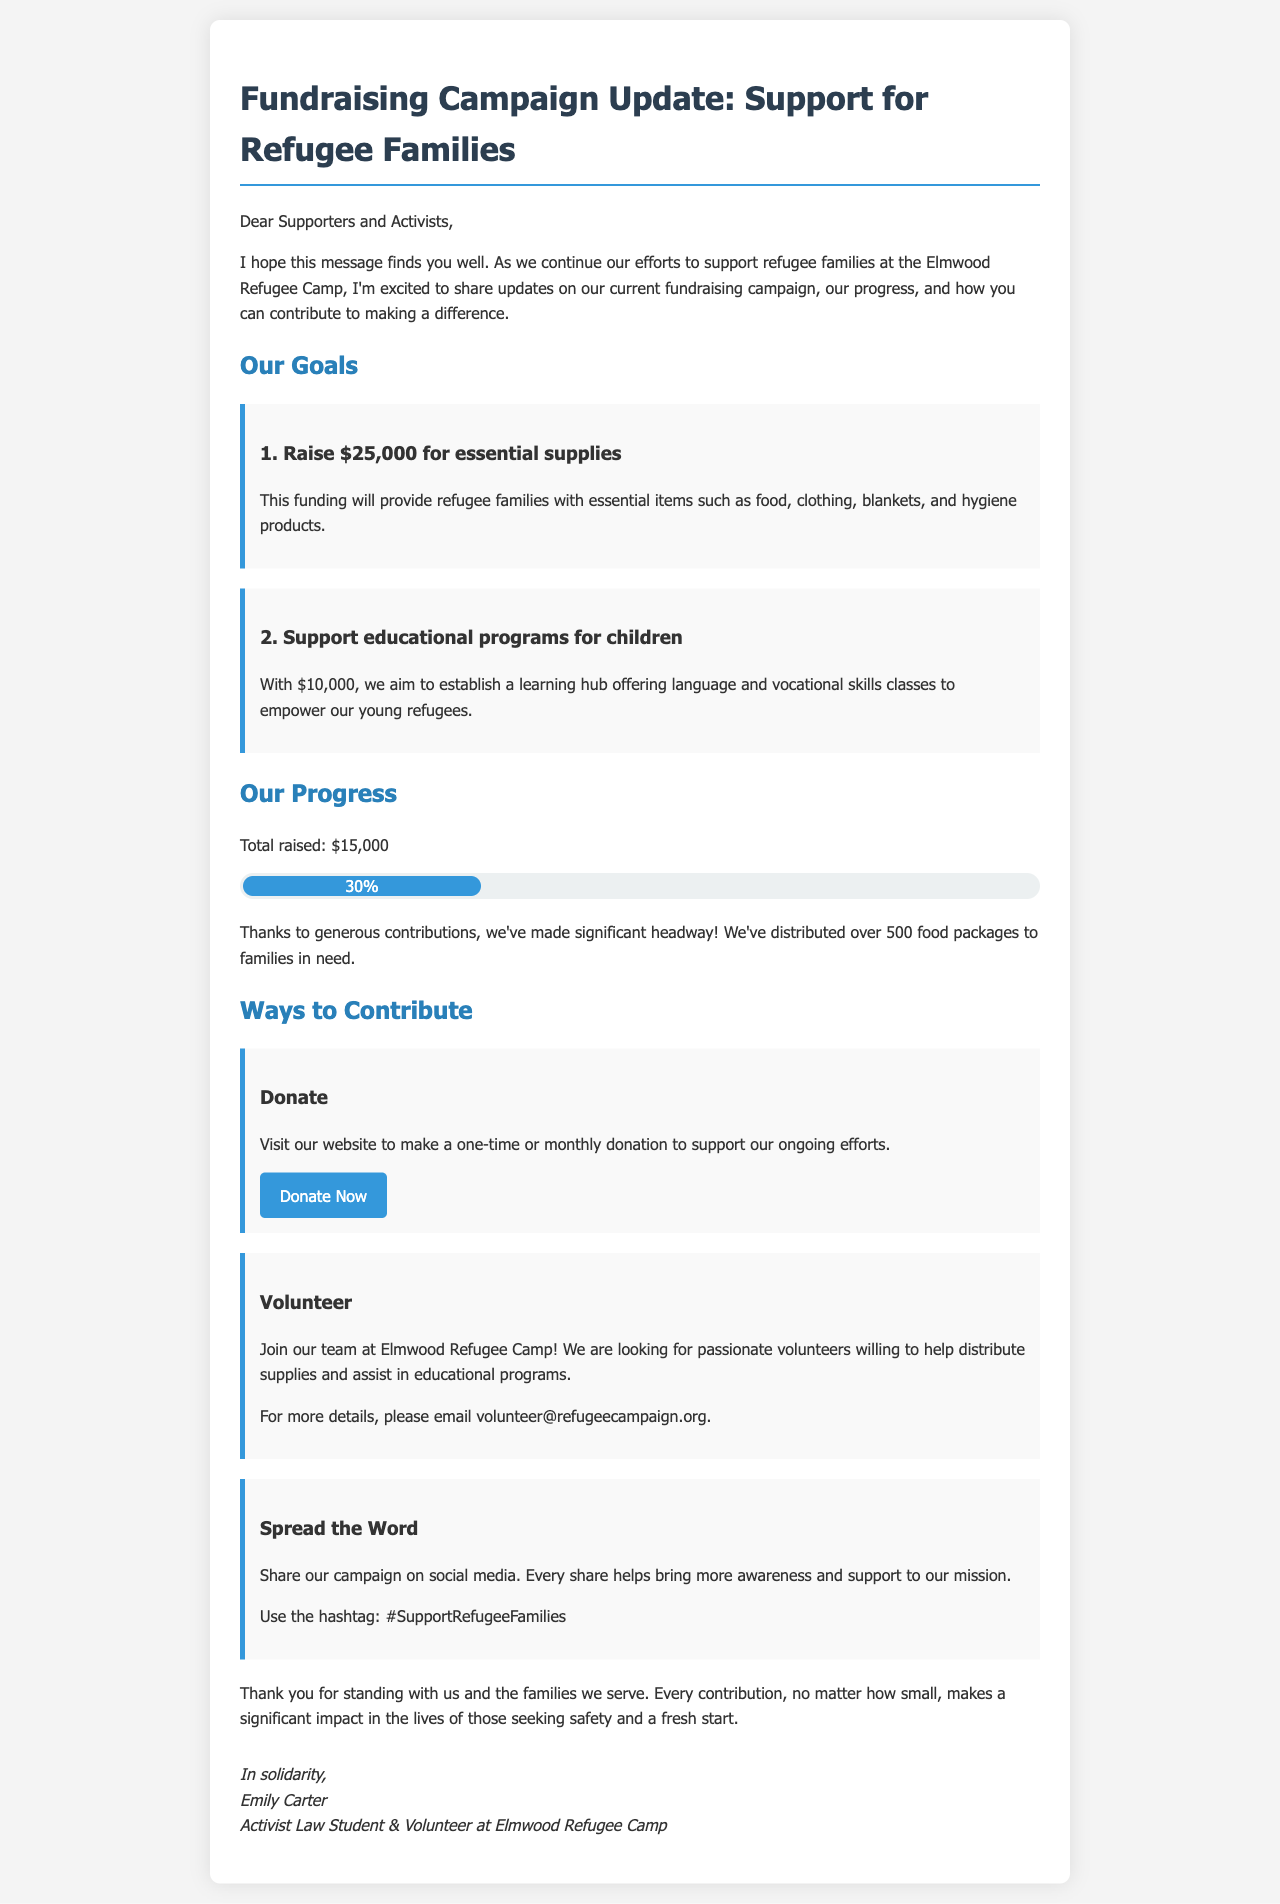What is the main fundraising goal? The main fundraising goal is to raise $25,000 for essential supplies for refugee families.
Answer: $25,000 How much has been raised so far? The document states that a total of $15,000 has been raised to date.
Answer: $15,000 What is one of the key items provided to families in need? The document mentions food as one of the essential items provided to families.
Answer: food How many food packages have been distributed? The document mentions that over 500 food packages have been distributed to families.
Answer: 500 What percentage of the goal has been achieved? The document indicates that 30% of the total fundraising goal has been achieved.
Answer: 30% Who can be contacted for volunteering opportunities? The document provides an email address for volunteering inquiries.
Answer: volunteer@refugeecampaign.org What is a way to spread awareness about the campaign? The document suggests sharing the campaign on social media as a way to spread awareness.
Answer: share on social media What is the purpose of the educational programs mentioned? The educational programs aim to empower young refugees with language and vocational skills.
Answer: empower young refugees Who signed the email? The email is signed by Emily Carter.
Answer: Emily Carter 